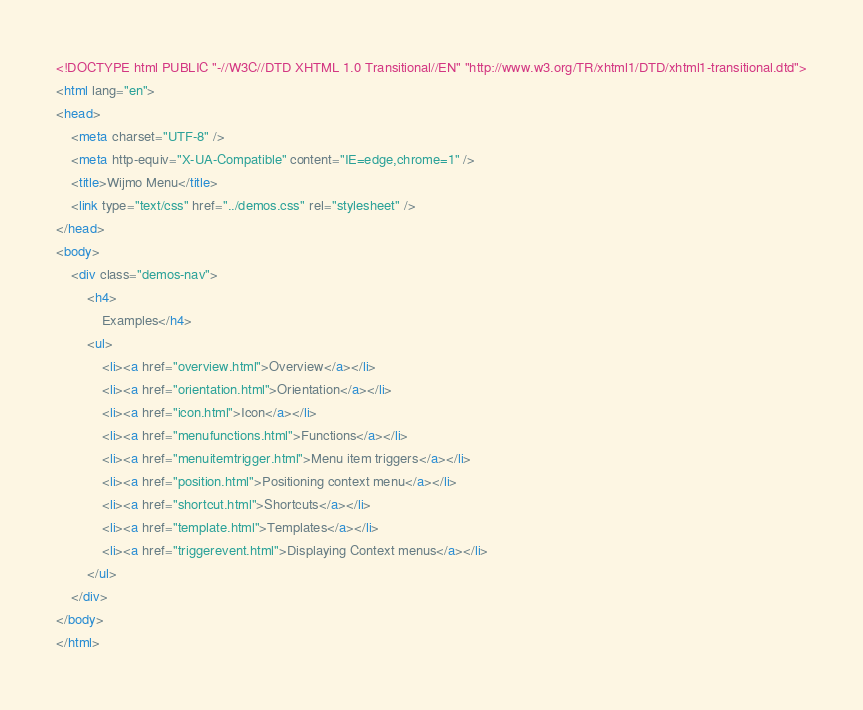Convert code to text. <code><loc_0><loc_0><loc_500><loc_500><_HTML_><!DOCTYPE html PUBLIC "-//W3C//DTD XHTML 1.0 Transitional//EN" "http://www.w3.org/TR/xhtml1/DTD/xhtml1-transitional.dtd">
<html lang="en">
<head>
    <meta charset="UTF-8" />
    <meta http-equiv="X-UA-Compatible" content="IE=edge,chrome=1" />
    <title>Wijmo Menu</title>
    <link type="text/css" href="../demos.css" rel="stylesheet" />
</head>
<body>
    <div class="demos-nav">
        <h4>
            Examples</h4>
        <ul>
            <li><a href="overview.html">Overview</a></li>
            <li><a href="orientation.html">Orientation</a></li>            
            <li><a href="icon.html">Icon</a></li>
            <li><a href="menufunctions.html">Functions</a></li>
            <li><a href="menuitemtrigger.html">Menu item triggers</a></li>
            <li><a href="position.html">Positioning context menu</a></li>
            <li><a href="shortcut.html">Shortcuts</a></li>
            <li><a href="template.html">Templates</a></li>
            <li><a href="triggerevent.html">Displaying Context menus</a></li>
        </ul>
    </div>
</body>
</html>
</code> 